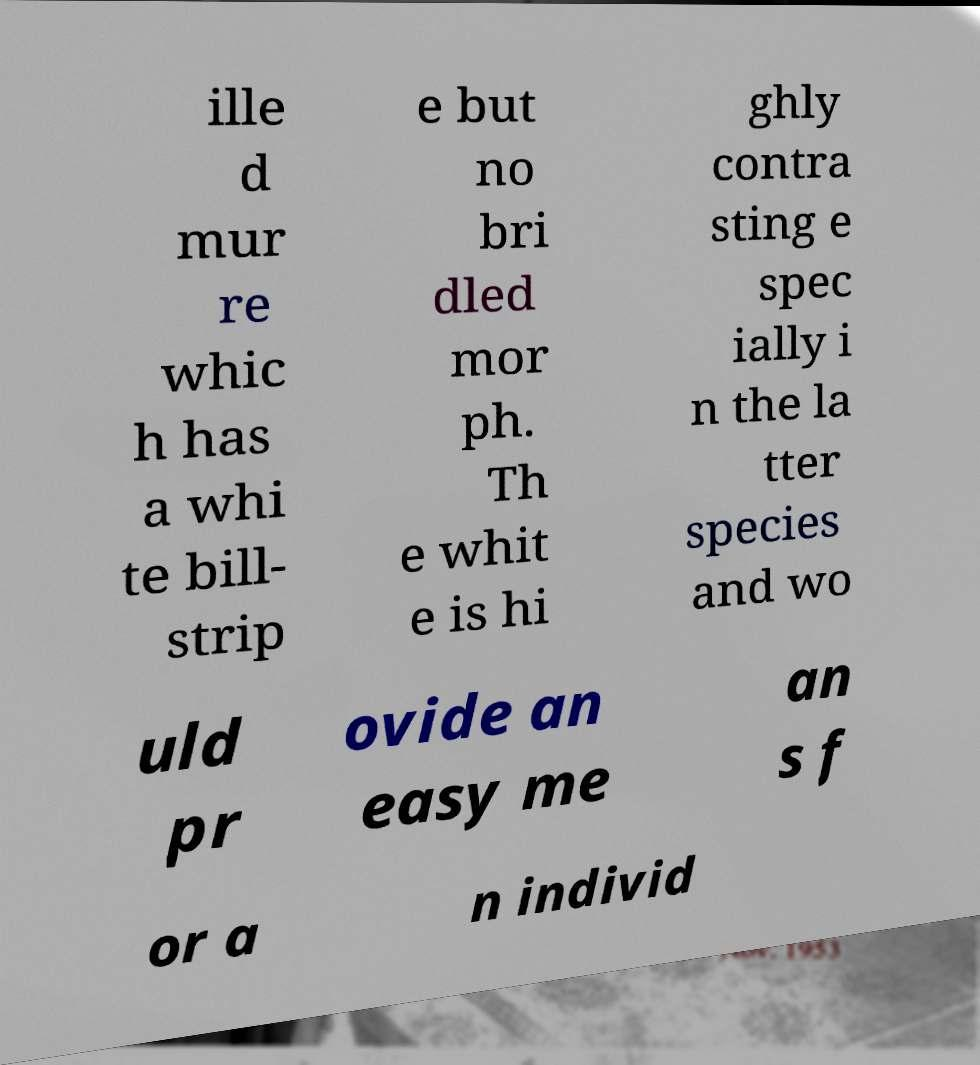There's text embedded in this image that I need extracted. Can you transcribe it verbatim? ille d mur re whic h has a whi te bill- strip e but no bri dled mor ph. Th e whit e is hi ghly contra sting e spec ially i n the la tter species and wo uld pr ovide an easy me an s f or a n individ 